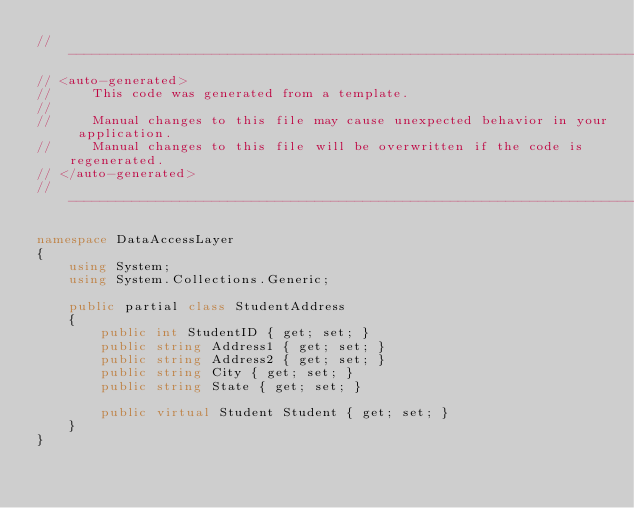Convert code to text. <code><loc_0><loc_0><loc_500><loc_500><_C#_>//------------------------------------------------------------------------------
// <auto-generated>
//     This code was generated from a template.
//
//     Manual changes to this file may cause unexpected behavior in your application.
//     Manual changes to this file will be overwritten if the code is regenerated.
// </auto-generated>
//------------------------------------------------------------------------------

namespace DataAccessLayer
{
    using System;
    using System.Collections.Generic;
    
    public partial class StudentAddress
    {
        public int StudentID { get; set; }
        public string Address1 { get; set; }
        public string Address2 { get; set; }
        public string City { get; set; }
        public string State { get; set; }
    
        public virtual Student Student { get; set; }
    }
}
</code> 